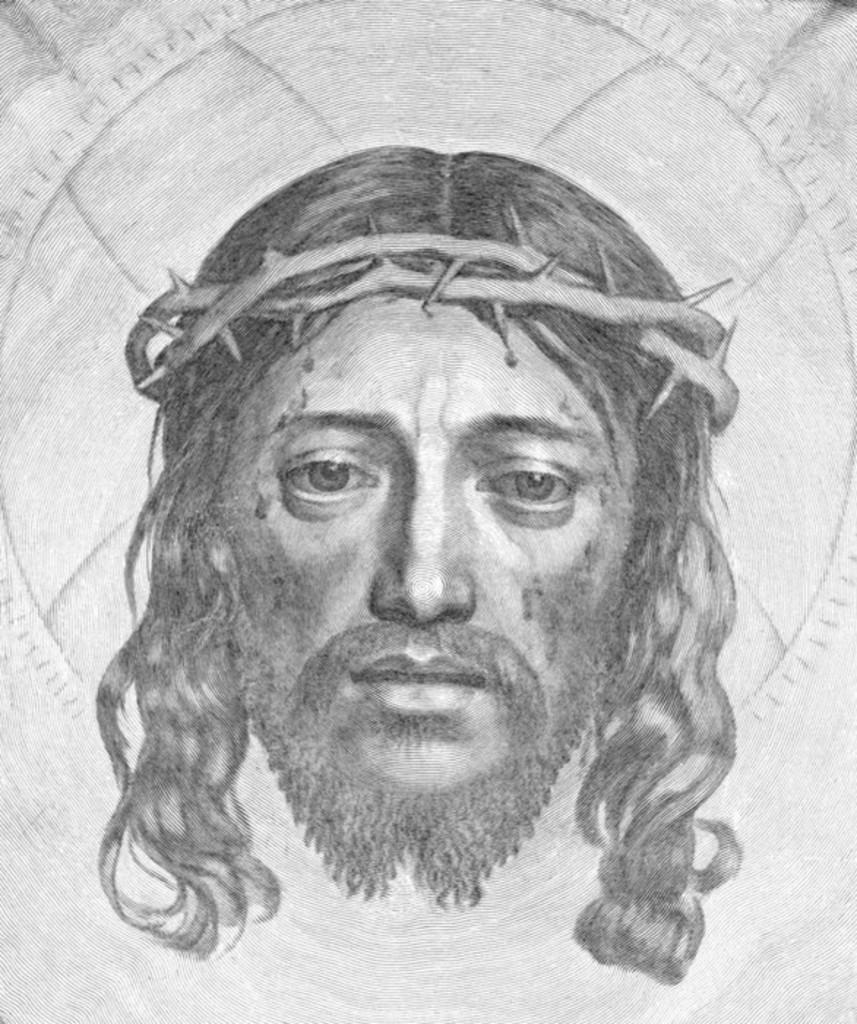What is depicted in the image? There is a drawing of a person in the image. What advice does the person in the drawing give to the doctor in the image? There is no doctor or advice present in the image; it only features a drawing of a person. 